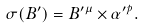Convert formula to latex. <formula><loc_0><loc_0><loc_500><loc_500>\sigma ( B ^ { \prime } ) = B ^ { \prime \mu } \times \alpha ^ { \prime p } .</formula> 